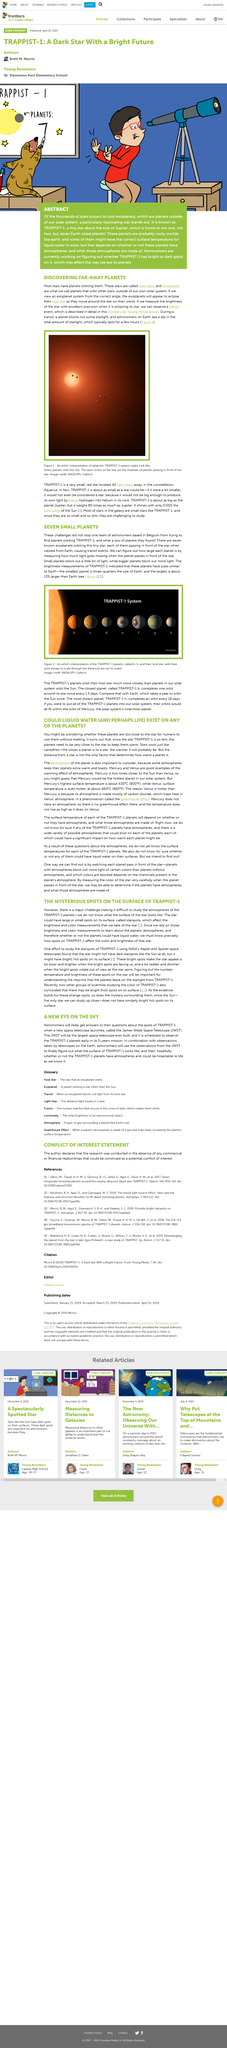List a handful of essential elements in this visual. NASA's Kepler and Spitzer telescopes have been utilized in the study of exoplanet transits. The TRAPPIST-1 planets orbit their host star much more closely than planets in our solar system, with the closest planet orbiting its star at a distance equivalent to that of Mercury to the Sun in our own solar system. The team of astronomers was based in Belgium, as stated in the article. Large or small spots on a star are called starspots. The search for liquid water, an essential ingredient for life as we know it, is the primary objective of our mission to explore exoplanets. 